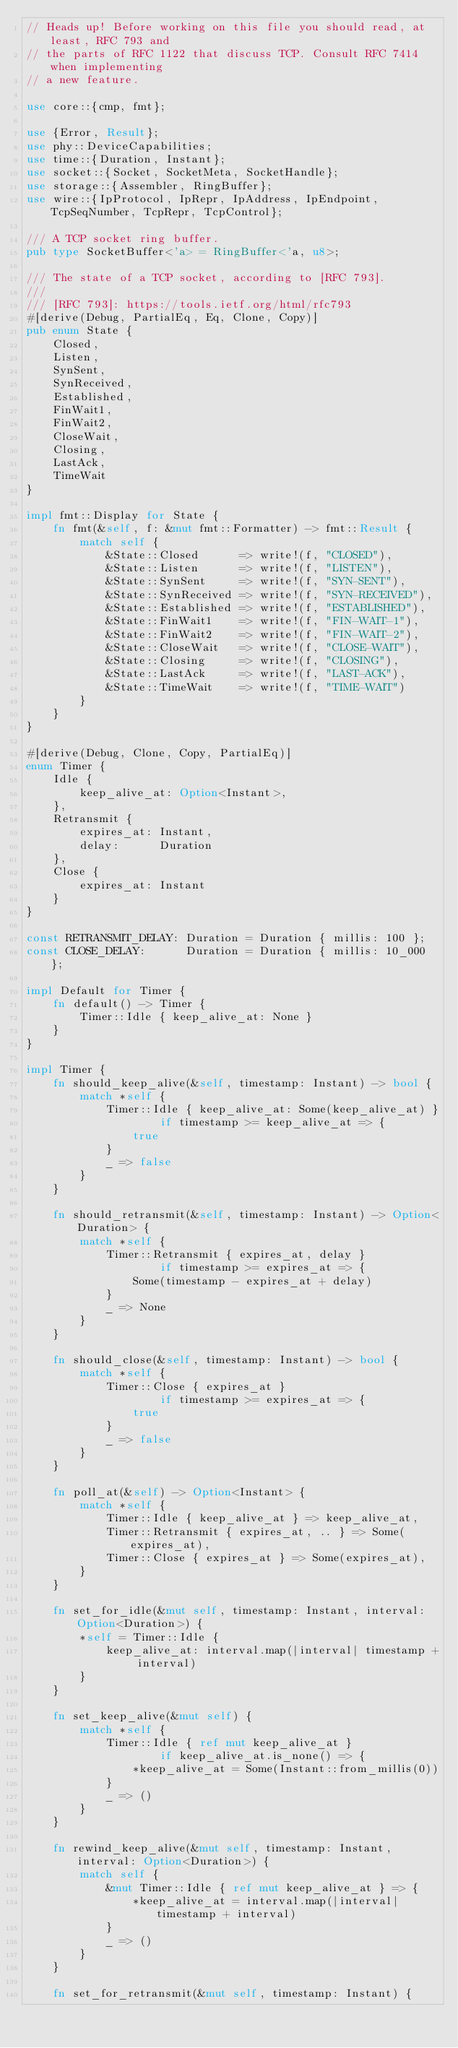<code> <loc_0><loc_0><loc_500><loc_500><_Rust_>// Heads up! Before working on this file you should read, at least, RFC 793 and
// the parts of RFC 1122 that discuss TCP. Consult RFC 7414 when implementing
// a new feature.

use core::{cmp, fmt};

use {Error, Result};
use phy::DeviceCapabilities;
use time::{Duration, Instant};
use socket::{Socket, SocketMeta, SocketHandle};
use storage::{Assembler, RingBuffer};
use wire::{IpProtocol, IpRepr, IpAddress, IpEndpoint, TcpSeqNumber, TcpRepr, TcpControl};

/// A TCP socket ring buffer.
pub type SocketBuffer<'a> = RingBuffer<'a, u8>;

/// The state of a TCP socket, according to [RFC 793].
///
/// [RFC 793]: https://tools.ietf.org/html/rfc793
#[derive(Debug, PartialEq, Eq, Clone, Copy)]
pub enum State {
    Closed,
    Listen,
    SynSent,
    SynReceived,
    Established,
    FinWait1,
    FinWait2,
    CloseWait,
    Closing,
    LastAck,
    TimeWait
}

impl fmt::Display for State {
    fn fmt(&self, f: &mut fmt::Formatter) -> fmt::Result {
        match self {
            &State::Closed      => write!(f, "CLOSED"),
            &State::Listen      => write!(f, "LISTEN"),
            &State::SynSent     => write!(f, "SYN-SENT"),
            &State::SynReceived => write!(f, "SYN-RECEIVED"),
            &State::Established => write!(f, "ESTABLISHED"),
            &State::FinWait1    => write!(f, "FIN-WAIT-1"),
            &State::FinWait2    => write!(f, "FIN-WAIT-2"),
            &State::CloseWait   => write!(f, "CLOSE-WAIT"),
            &State::Closing     => write!(f, "CLOSING"),
            &State::LastAck     => write!(f, "LAST-ACK"),
            &State::TimeWait    => write!(f, "TIME-WAIT")
        }
    }
}

#[derive(Debug, Clone, Copy, PartialEq)]
enum Timer {
    Idle {
        keep_alive_at: Option<Instant>,
    },
    Retransmit {
        expires_at: Instant,
        delay:      Duration
    },
    Close {
        expires_at: Instant
    }
}

const RETRANSMIT_DELAY: Duration = Duration { millis: 100 };
const CLOSE_DELAY:      Duration = Duration { millis: 10_000 };

impl Default for Timer {
    fn default() -> Timer {
        Timer::Idle { keep_alive_at: None }
    }
}

impl Timer {
    fn should_keep_alive(&self, timestamp: Instant) -> bool {
        match *self {
            Timer::Idle { keep_alive_at: Some(keep_alive_at) }
                    if timestamp >= keep_alive_at => {
                true
            }
            _ => false
        }
    }

    fn should_retransmit(&self, timestamp: Instant) -> Option<Duration> {
        match *self {
            Timer::Retransmit { expires_at, delay }
                    if timestamp >= expires_at => {
                Some(timestamp - expires_at + delay)
            }
            _ => None
        }
    }

    fn should_close(&self, timestamp: Instant) -> bool {
        match *self {
            Timer::Close { expires_at }
                    if timestamp >= expires_at => {
                true
            }
            _ => false
        }
    }

    fn poll_at(&self) -> Option<Instant> {
        match *self {
            Timer::Idle { keep_alive_at } => keep_alive_at,
            Timer::Retransmit { expires_at, .. } => Some(expires_at),
            Timer::Close { expires_at } => Some(expires_at),
        }
    }

    fn set_for_idle(&mut self, timestamp: Instant, interval: Option<Duration>) {
        *self = Timer::Idle {
            keep_alive_at: interval.map(|interval| timestamp + interval)
        }
    }

    fn set_keep_alive(&mut self) {
        match *self {
            Timer::Idle { ref mut keep_alive_at }
                    if keep_alive_at.is_none() => {
                *keep_alive_at = Some(Instant::from_millis(0))
            }
            _ => ()
        }
    }

    fn rewind_keep_alive(&mut self, timestamp: Instant, interval: Option<Duration>) {
        match self {
            &mut Timer::Idle { ref mut keep_alive_at } => {
                *keep_alive_at = interval.map(|interval| timestamp + interval)
            }
            _ => ()
        }
    }

    fn set_for_retransmit(&mut self, timestamp: Instant) {</code> 